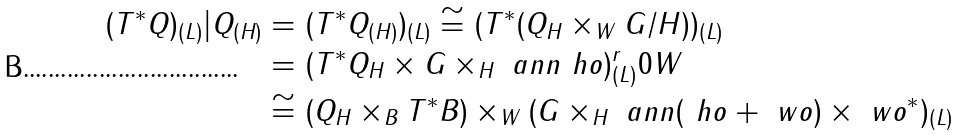<formula> <loc_0><loc_0><loc_500><loc_500>( T ^ { * } Q ) _ { ( L ) } | Q _ { ( H ) } & = ( T ^ { * } Q _ { ( H ) } ) _ { ( L ) } \cong ( T ^ { * } ( Q _ { H } \times _ { W } G / H ) ) _ { ( L ) } \\ & = ( T ^ { * } Q _ { H } \times G \times _ { H } \ a n n \ h o ) _ { ( L ) } ^ { r } { 0 } W \\ & \cong ( Q _ { H } \times _ { B } T ^ { * } B ) \times _ { W } ( G \times _ { H } \ a n n ( \ h o + \ w o ) \times \ w o ^ { * } ) _ { ( L ) }</formula> 